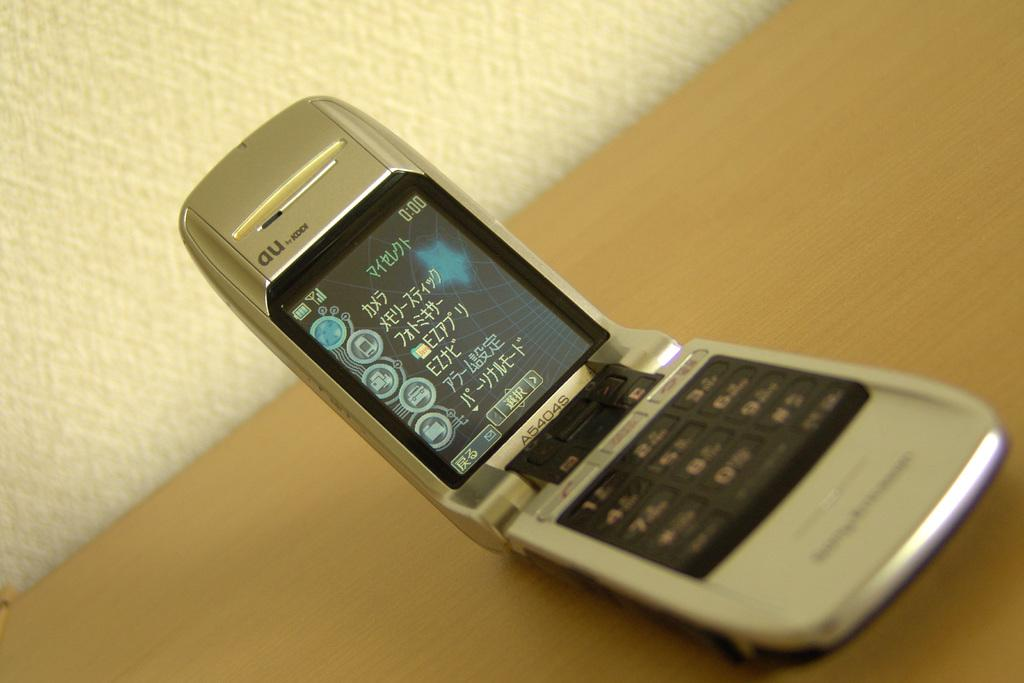<image>
Render a clear and concise summary of the photo. The time in the right hand corner of the cellphone screen is 0:00. 